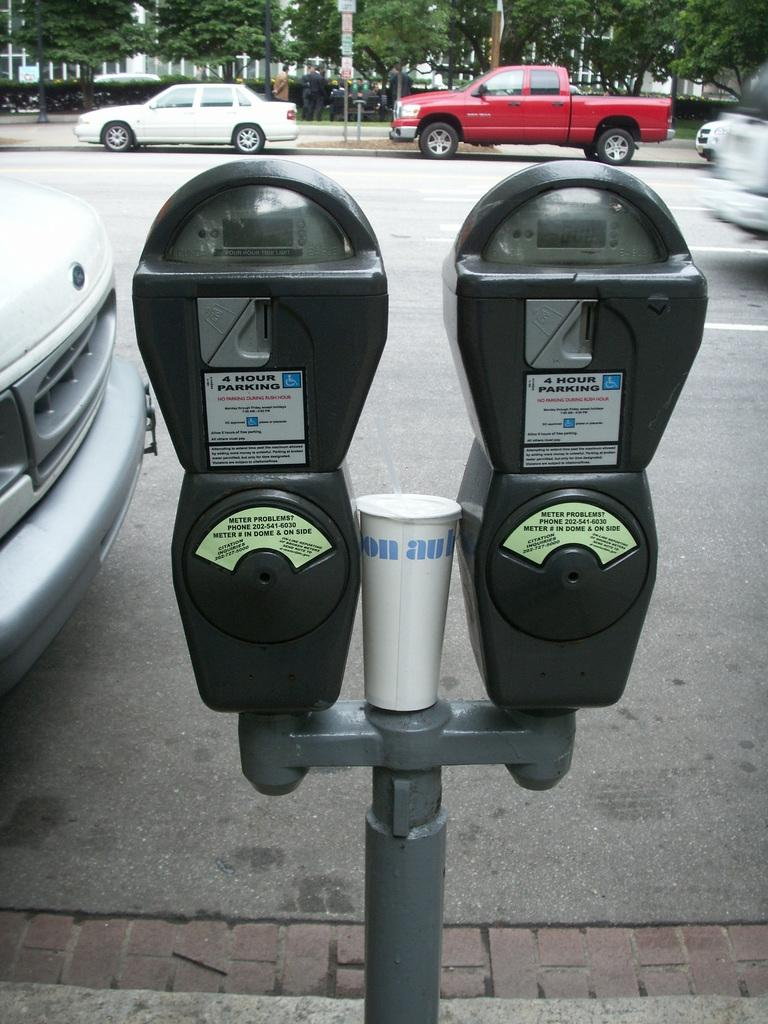<image>
Summarize the visual content of the image. Two parking meters by a white Ford say 4 Hour Parking. 